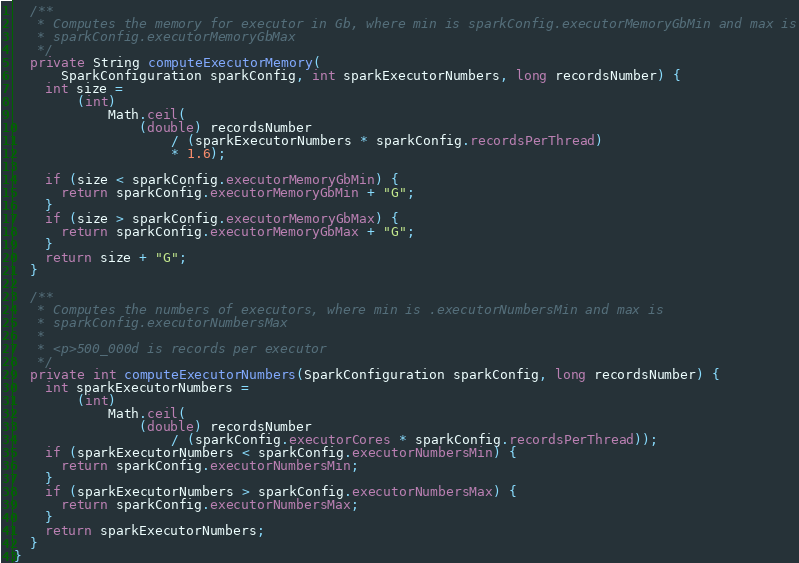<code> <loc_0><loc_0><loc_500><loc_500><_Java_>
  /**
   * Computes the memory for executor in Gb, where min is sparkConfig.executorMemoryGbMin and max is
   * sparkConfig.executorMemoryGbMax
   */
  private String computeExecutorMemory(
      SparkConfiguration sparkConfig, int sparkExecutorNumbers, long recordsNumber) {
    int size =
        (int)
            Math.ceil(
                (double) recordsNumber
                    / (sparkExecutorNumbers * sparkConfig.recordsPerThread)
                    * 1.6);

    if (size < sparkConfig.executorMemoryGbMin) {
      return sparkConfig.executorMemoryGbMin + "G";
    }
    if (size > sparkConfig.executorMemoryGbMax) {
      return sparkConfig.executorMemoryGbMax + "G";
    }
    return size + "G";
  }

  /**
   * Computes the numbers of executors, where min is .executorNumbersMin and max is
   * sparkConfig.executorNumbersMax
   *
   * <p>500_000d is records per executor
   */
  private int computeExecutorNumbers(SparkConfiguration sparkConfig, long recordsNumber) {
    int sparkExecutorNumbers =
        (int)
            Math.ceil(
                (double) recordsNumber
                    / (sparkConfig.executorCores * sparkConfig.recordsPerThread));
    if (sparkExecutorNumbers < sparkConfig.executorNumbersMin) {
      return sparkConfig.executorNumbersMin;
    }
    if (sparkExecutorNumbers > sparkConfig.executorNumbersMax) {
      return sparkConfig.executorNumbersMax;
    }
    return sparkExecutorNumbers;
  }
}
</code> 